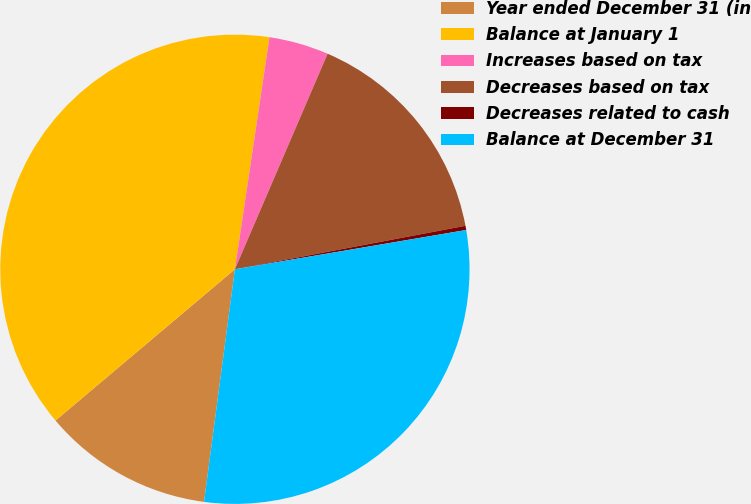<chart> <loc_0><loc_0><loc_500><loc_500><pie_chart><fcel>Year ended December 31 (in<fcel>Balance at January 1<fcel>Increases based on tax<fcel>Decreases based on tax<fcel>Decreases related to cash<fcel>Balance at December 31<nl><fcel>11.75%<fcel>38.51%<fcel>4.11%<fcel>15.57%<fcel>0.29%<fcel>29.78%<nl></chart> 